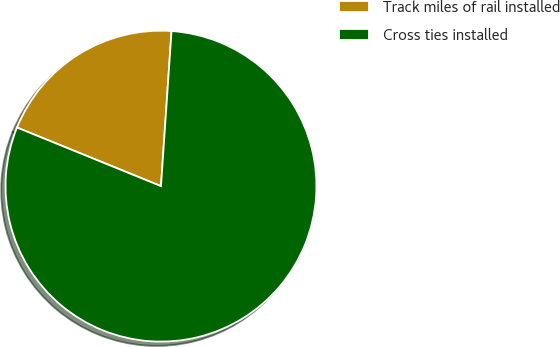Convert chart. <chart><loc_0><loc_0><loc_500><loc_500><pie_chart><fcel>Track miles of rail installed<fcel>Cross ties installed<nl><fcel>19.93%<fcel>80.07%<nl></chart> 